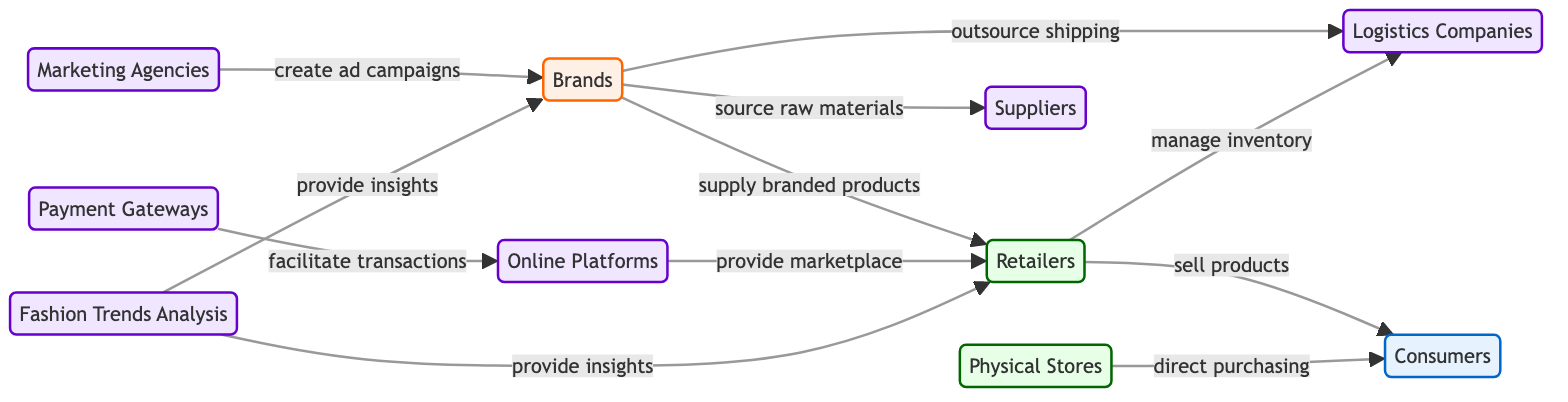What are the three main types of nodes in the diagram? The diagram contains three main types of nodes: Brands, Retailers, and Consumers, which represent the key players in the fashion retail ecosystem.
Answer: Brands, Retailers, Consumers How many edges connect the Brands node? The Brands node is connected to four different nodes: Retailers, Logistics, Suppliers, and Fashion Trends Analysis, indicating its various relationships within the ecosystem.
Answer: 4 What is the relationship between Retailers and Consumers? The relationship indicates that Retailers sell products directly to Consumers, which is fundamental in the retail process of the fashion ecosystem.
Answer: sell products Which node provides insights to both Brands and Retailers? The Fashion Trends Analysis node is connected to both Brands and Retailers, showing it serves both roles by offering valuable market insights.
Answer: Fashion Trends Analysis What role do Payment Gateways play in the diagram? Payment Gateways facilitate transactions between Online Platforms and Consumers, making them crucial for the financial aspect of online retail.
Answer: facilitate transactions How many support nodes are present in the diagram? The support nodes in the diagram are Logistics Companies, Suppliers, Online Platforms, Marketing Agencies, Physical Stores, Payment Gateways, and Fashion Trends Analysis, totaling seven nodes that help in the ecosystem.
Answer: 7 Which type of node directly interacts with consumers for purchasing? The Physical Stores node directly interacts with Consumers for purchasing, highlighting the traditional retail aspect of the fashion ecosystem.
Answer: Physical Stores What is the connection between Online Platforms and Retailers? Online Platforms provide a marketplace for Retailers, enabling them to sell their products online effectively and reach a broader audience.
Answer: provide marketplace 